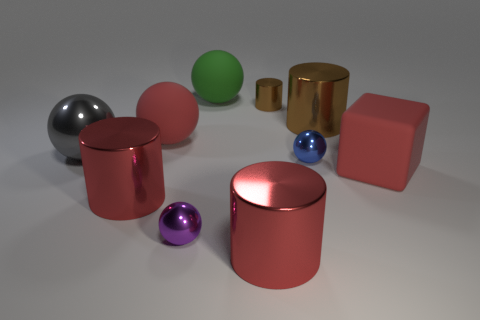Subtract all red spheres. How many spheres are left? 4 Subtract all gray balls. How many balls are left? 4 Subtract all brown balls. Subtract all cyan cubes. How many balls are left? 5 Subtract all cubes. How many objects are left? 9 Add 9 gray balls. How many gray balls are left? 10 Add 3 purple things. How many purple things exist? 4 Subtract 0 yellow cubes. How many objects are left? 10 Subtract all purple balls. Subtract all large red blocks. How many objects are left? 8 